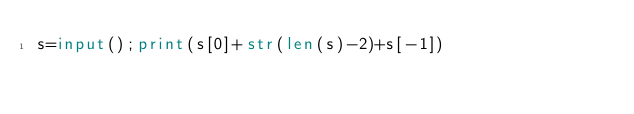Convert code to text. <code><loc_0><loc_0><loc_500><loc_500><_Python_>s=input();print(s[0]+str(len(s)-2)+s[-1])</code> 